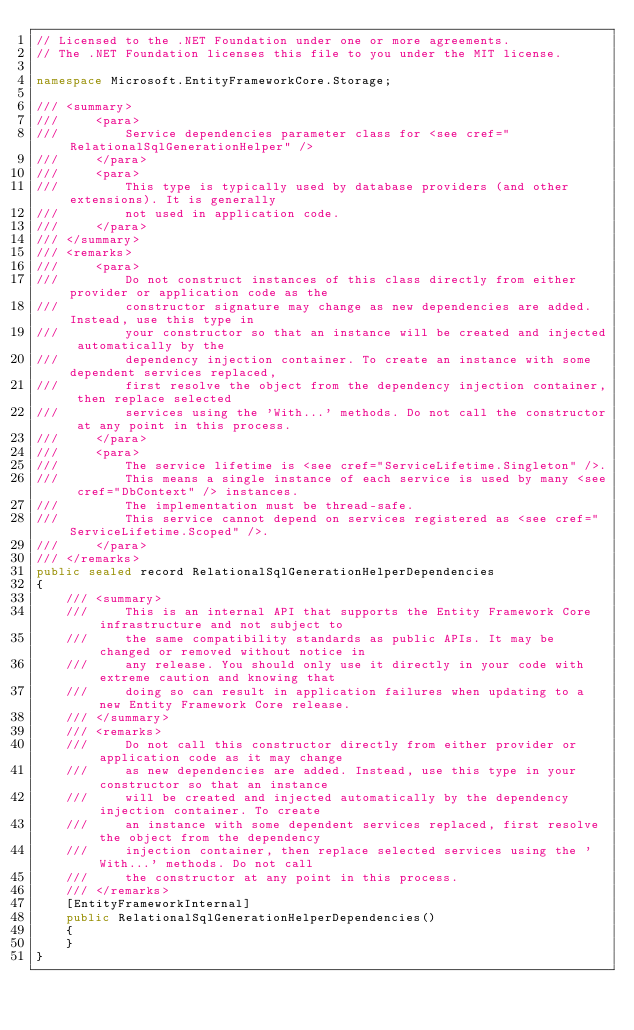Convert code to text. <code><loc_0><loc_0><loc_500><loc_500><_C#_>// Licensed to the .NET Foundation under one or more agreements.
// The .NET Foundation licenses this file to you under the MIT license.

namespace Microsoft.EntityFrameworkCore.Storage;

/// <summary>
///     <para>
///         Service dependencies parameter class for <see cref="RelationalSqlGenerationHelper" />
///     </para>
///     <para>
///         This type is typically used by database providers (and other extensions). It is generally
///         not used in application code.
///     </para>
/// </summary>
/// <remarks>
///     <para>
///         Do not construct instances of this class directly from either provider or application code as the
///         constructor signature may change as new dependencies are added. Instead, use this type in
///         your constructor so that an instance will be created and injected automatically by the
///         dependency injection container. To create an instance with some dependent services replaced,
///         first resolve the object from the dependency injection container, then replace selected
///         services using the 'With...' methods. Do not call the constructor at any point in this process.
///     </para>
///     <para>
///         The service lifetime is <see cref="ServiceLifetime.Singleton" />.
///         This means a single instance of each service is used by many <see cref="DbContext" /> instances.
///         The implementation must be thread-safe.
///         This service cannot depend on services registered as <see cref="ServiceLifetime.Scoped" />.
///     </para>
/// </remarks>
public sealed record RelationalSqlGenerationHelperDependencies
{
    /// <summary>
    ///     This is an internal API that supports the Entity Framework Core infrastructure and not subject to
    ///     the same compatibility standards as public APIs. It may be changed or removed without notice in
    ///     any release. You should only use it directly in your code with extreme caution and knowing that
    ///     doing so can result in application failures when updating to a new Entity Framework Core release.
    /// </summary>
    /// <remarks>
    ///     Do not call this constructor directly from either provider or application code as it may change
    ///     as new dependencies are added. Instead, use this type in your constructor so that an instance
    ///     will be created and injected automatically by the dependency injection container. To create
    ///     an instance with some dependent services replaced, first resolve the object from the dependency
    ///     injection container, then replace selected services using the 'With...' methods. Do not call
    ///     the constructor at any point in this process.
    /// </remarks>
    [EntityFrameworkInternal]
    public RelationalSqlGenerationHelperDependencies()
    {
    }
}
</code> 